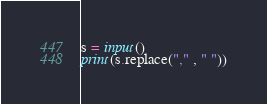Convert code to text. <code><loc_0><loc_0><loc_500><loc_500><_Python_>s = input()
print(s.replace("," , " "))</code> 